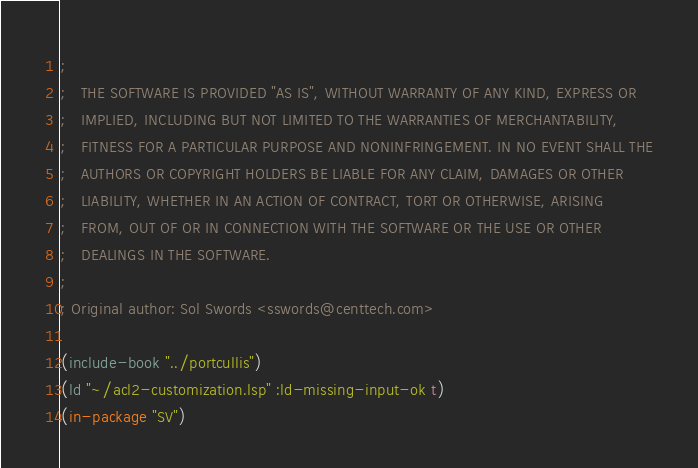Convert code to text. <code><loc_0><loc_0><loc_500><loc_500><_Lisp_>;
;   THE SOFTWARE IS PROVIDED "AS IS", WITHOUT WARRANTY OF ANY KIND, EXPRESS OR
;   IMPLIED, INCLUDING BUT NOT LIMITED TO THE WARRANTIES OF MERCHANTABILITY,
;   FITNESS FOR A PARTICULAR PURPOSE AND NONINFRINGEMENT. IN NO EVENT SHALL THE
;   AUTHORS OR COPYRIGHT HOLDERS BE LIABLE FOR ANY CLAIM, DAMAGES OR OTHER
;   LIABILITY, WHETHER IN AN ACTION OF CONTRACT, TORT OR OTHERWISE, ARISING
;   FROM, OUT OF OR IN CONNECTION WITH THE SOFTWARE OR THE USE OR OTHER
;   DEALINGS IN THE SOFTWARE.
;
; Original author: Sol Swords <sswords@centtech.com>

(include-book "../portcullis")
(ld "~/acl2-customization.lsp" :ld-missing-input-ok t)
(in-package "SV")
</code> 